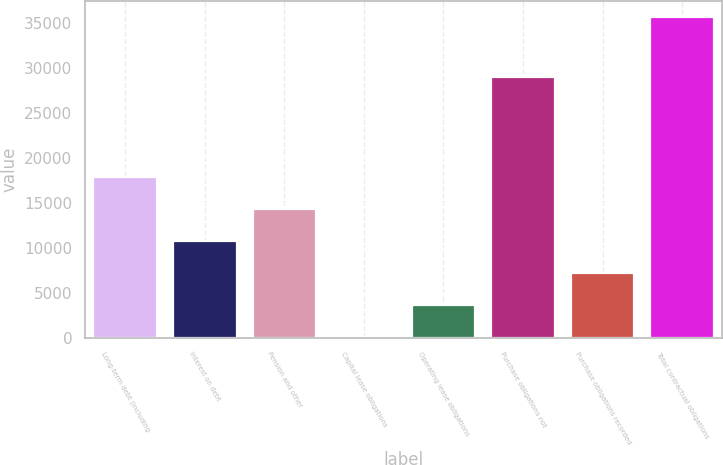Convert chart to OTSL. <chart><loc_0><loc_0><loc_500><loc_500><bar_chart><fcel>Long-term debt (including<fcel>Interest on debt<fcel>Pension and other<fcel>Capital lease obligations<fcel>Operating lease obligations<fcel>Purchase obligations not<fcel>Purchase obligations recorded<fcel>Total contractual obligations<nl><fcel>17847<fcel>10719.4<fcel>14283.2<fcel>28<fcel>3591.8<fcel>29070<fcel>7155.6<fcel>35666<nl></chart> 